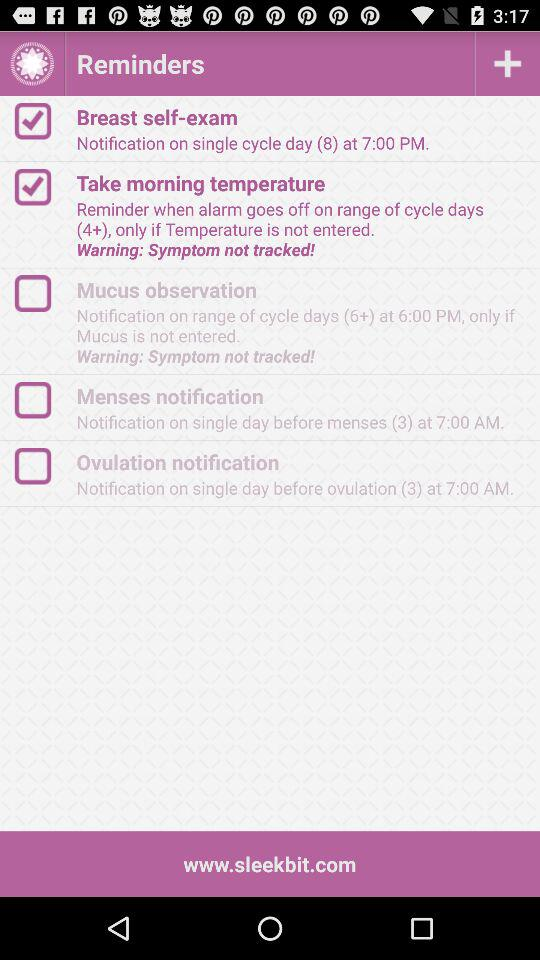How many reminders have a cycle day range of 6 or more?
Answer the question using a single word or phrase. 2 